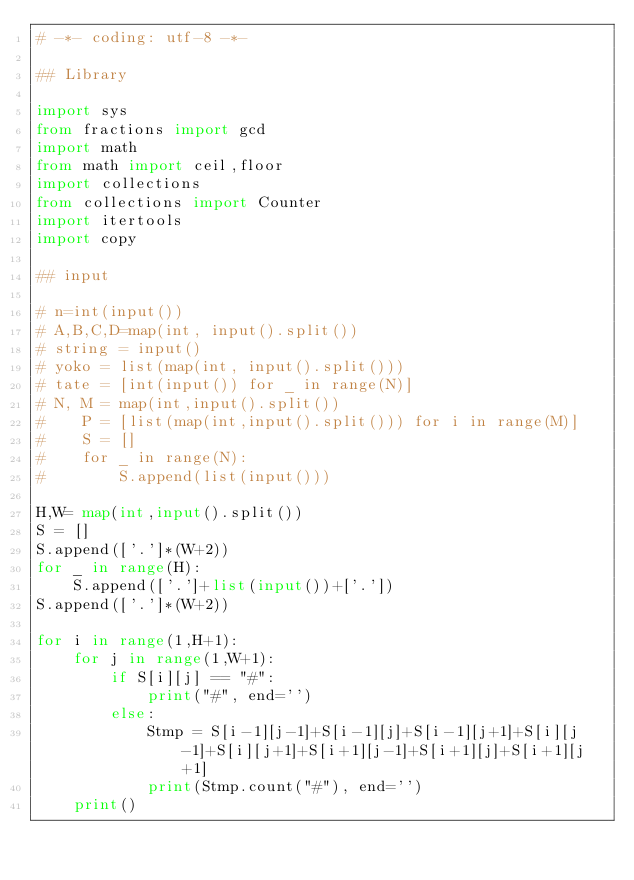Convert code to text. <code><loc_0><loc_0><loc_500><loc_500><_Python_># -*- coding: utf-8 -*-

## Library

import sys
from fractions import gcd
import math
from math import ceil,floor
import collections
from collections import Counter
import itertools
import copy

## input

# n=int(input())
# A,B,C,D=map(int, input().split())
# string = input()
# yoko = list(map(int, input().split()))
# tate = [int(input()) for _ in range(N)]
# N, M = map(int,input().split()) 
#    P = [list(map(int,input().split())) for i in range(M)]
#    S = []
#    for _ in range(N):
#        S.append(list(input()))

H,W= map(int,input().split()) 
S = []
S.append(['.']*(W+2))
for _ in range(H):
    S.append(['.']+list(input())+['.'])
S.append(['.']*(W+2))

for i in range(1,H+1):
    for j in range(1,W+1):
        if S[i][j] == "#":
            print("#", end='')
        else:
            Stmp = S[i-1][j-1]+S[i-1][j]+S[i-1][j+1]+S[i][j-1]+S[i][j+1]+S[i+1][j-1]+S[i+1][j]+S[i+1][j+1]
            print(Stmp.count("#"), end='')
    print()
</code> 